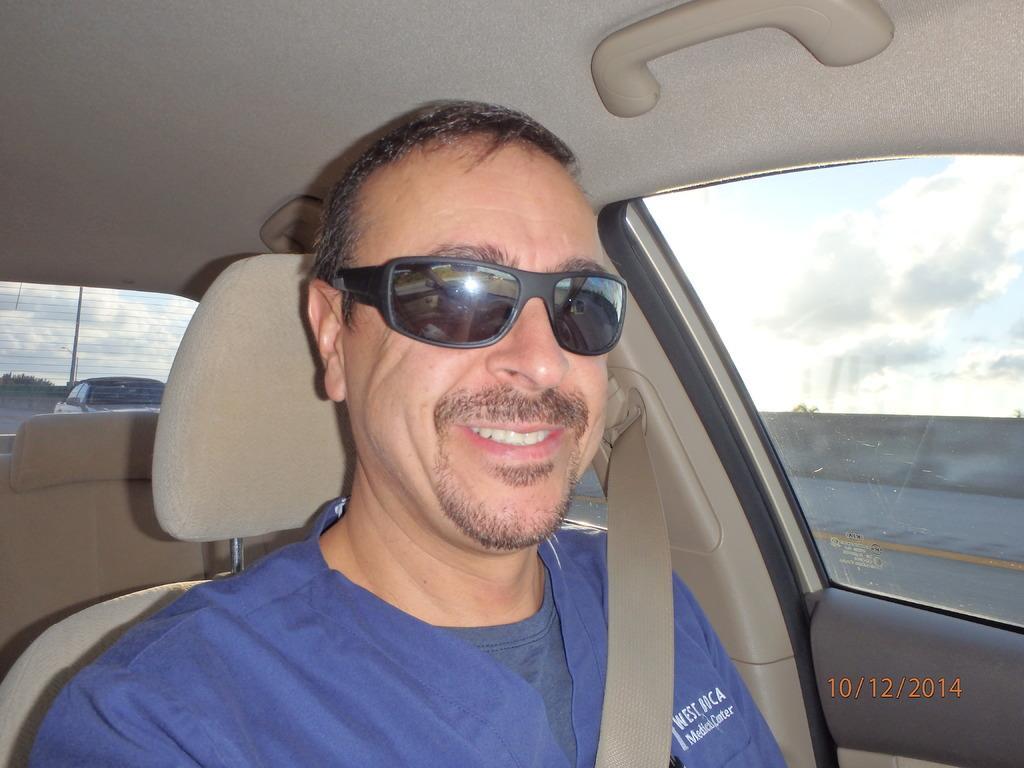In one or two sentences, can you explain what this image depicts? Man in blue t-shirt who is wearing goggles is sitting on the seat in the car. Behind him, we see a car moving on the road from the glass of the car. On the right side of the picture, we see sky and clouds from the window. 